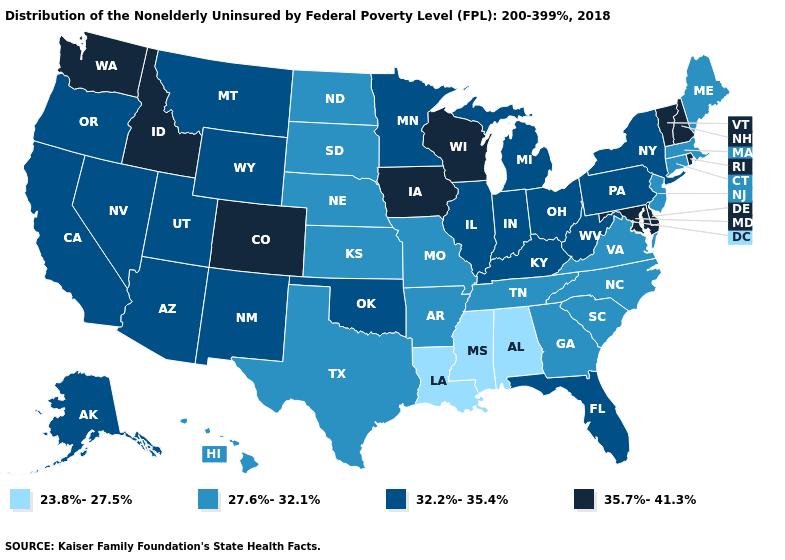Name the states that have a value in the range 23.8%-27.5%?
Give a very brief answer. Alabama, Louisiana, Mississippi. Among the states that border Pennsylvania , does New Jersey have the highest value?
Keep it brief. No. Name the states that have a value in the range 35.7%-41.3%?
Give a very brief answer. Colorado, Delaware, Idaho, Iowa, Maryland, New Hampshire, Rhode Island, Vermont, Washington, Wisconsin. What is the value of North Dakota?
Write a very short answer. 27.6%-32.1%. Does Nevada have the highest value in the West?
Write a very short answer. No. What is the value of Massachusetts?
Short answer required. 27.6%-32.1%. Name the states that have a value in the range 35.7%-41.3%?
Give a very brief answer. Colorado, Delaware, Idaho, Iowa, Maryland, New Hampshire, Rhode Island, Vermont, Washington, Wisconsin. Among the states that border Iowa , which have the highest value?
Give a very brief answer. Wisconsin. Does the map have missing data?
Keep it brief. No. Among the states that border Florida , which have the highest value?
Keep it brief. Georgia. What is the highest value in states that border Michigan?
Keep it brief. 35.7%-41.3%. Name the states that have a value in the range 23.8%-27.5%?
Concise answer only. Alabama, Louisiana, Mississippi. What is the highest value in the USA?
Concise answer only. 35.7%-41.3%. What is the value of California?
Be succinct. 32.2%-35.4%. Name the states that have a value in the range 35.7%-41.3%?
Give a very brief answer. Colorado, Delaware, Idaho, Iowa, Maryland, New Hampshire, Rhode Island, Vermont, Washington, Wisconsin. 